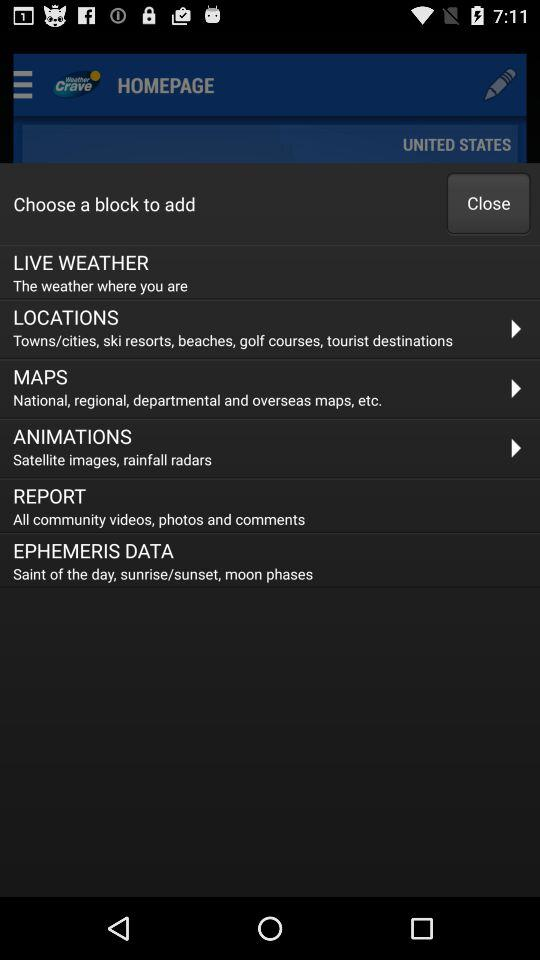What is the location? The location is the United States. 